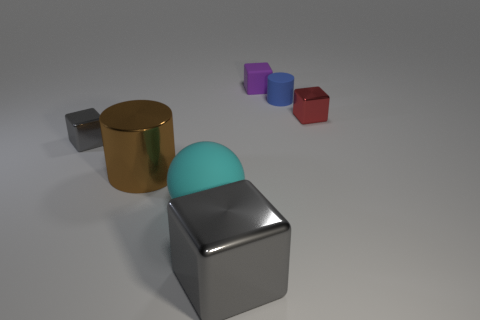Are there any other things that are the same material as the blue cylinder?
Offer a terse response. Yes. What number of small metallic things have the same color as the big block?
Make the answer very short. 1. There is another cube that is the same color as the big cube; what is its material?
Ensure brevity in your answer.  Metal. What color is the small object that is the same shape as the big brown thing?
Your response must be concise. Blue. There is a shiny thing that is to the right of the large brown object and in front of the small gray object; what size is it?
Your response must be concise. Large. There is a block that is behind the small blue cylinder in front of the purple block; what number of tiny red things are right of it?
Your answer should be very brief. 1. How many large things are gray shiny cubes or cyan rubber things?
Provide a succinct answer. 2. Is the cube that is right of the tiny blue matte thing made of the same material as the brown thing?
Your answer should be compact. Yes. What material is the cylinder in front of the block left of the cylinder that is on the left side of the purple thing?
Your response must be concise. Metal. What number of matte objects are cylinders or large cylinders?
Give a very brief answer. 1. 